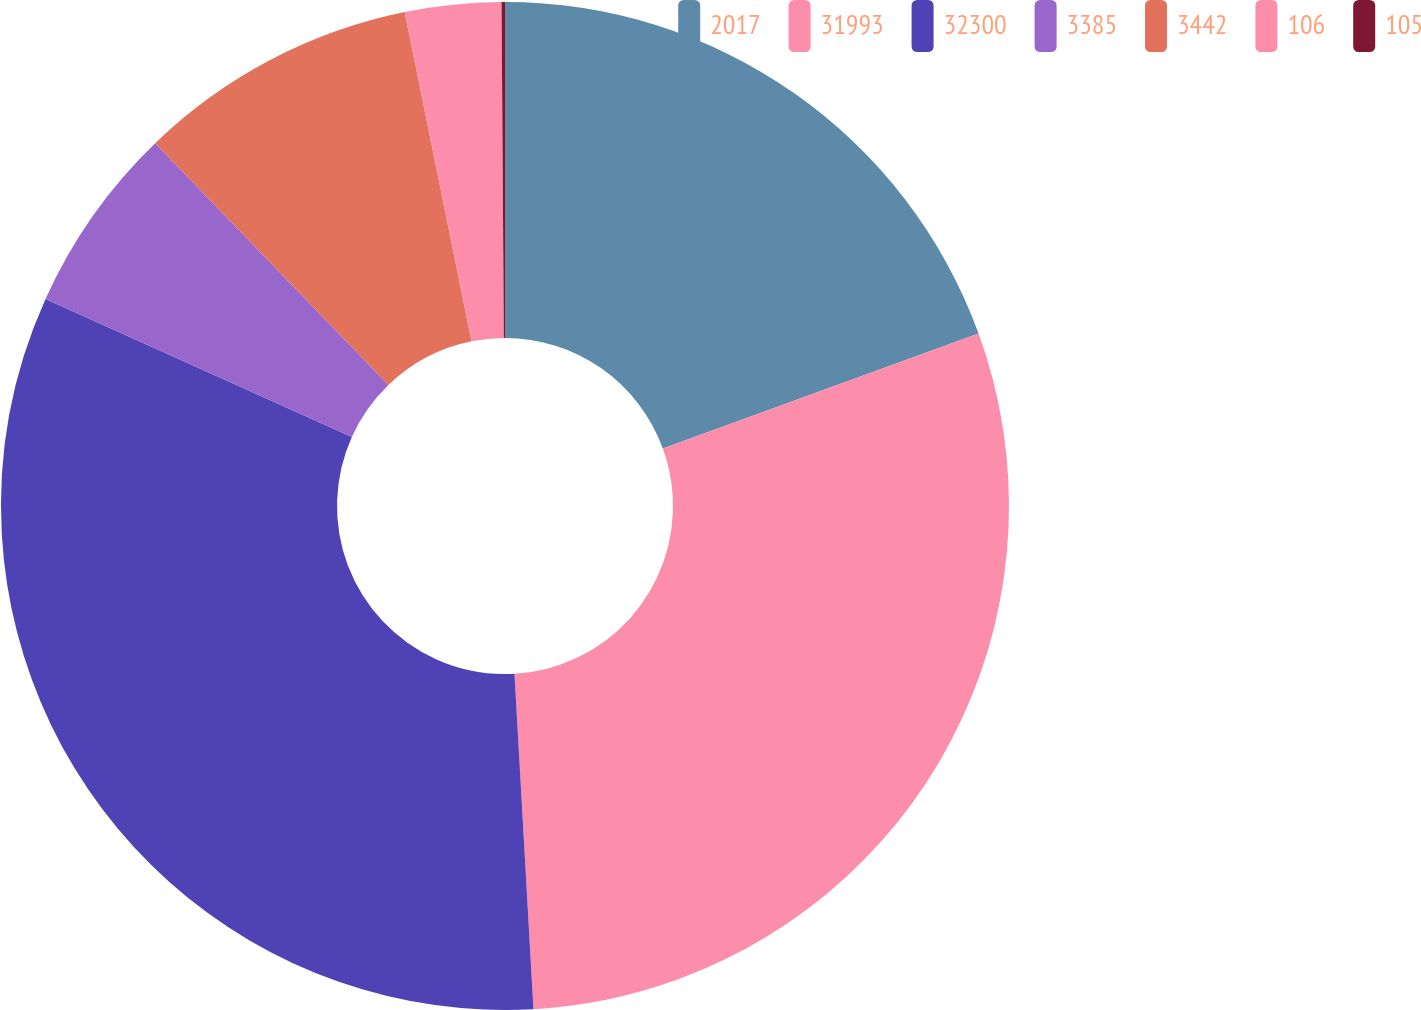<chart> <loc_0><loc_0><loc_500><loc_500><pie_chart><fcel>2017<fcel>31993<fcel>32300<fcel>3385<fcel>3442<fcel>106<fcel>105<nl><fcel>19.44%<fcel>29.66%<fcel>32.64%<fcel>6.05%<fcel>9.02%<fcel>3.08%<fcel>0.11%<nl></chart> 